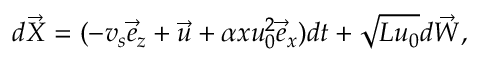<formula> <loc_0><loc_0><loc_500><loc_500>d \vec { X } = ( - v _ { s } \vec { e } _ { z } + \vec { u } + \alpha x u _ { 0 } ^ { 2 } \vec { e } _ { x } ) d t + \sqrt { L u _ { 0 } } d \vec { W } ,</formula> 